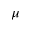<formula> <loc_0><loc_0><loc_500><loc_500>\mu</formula> 